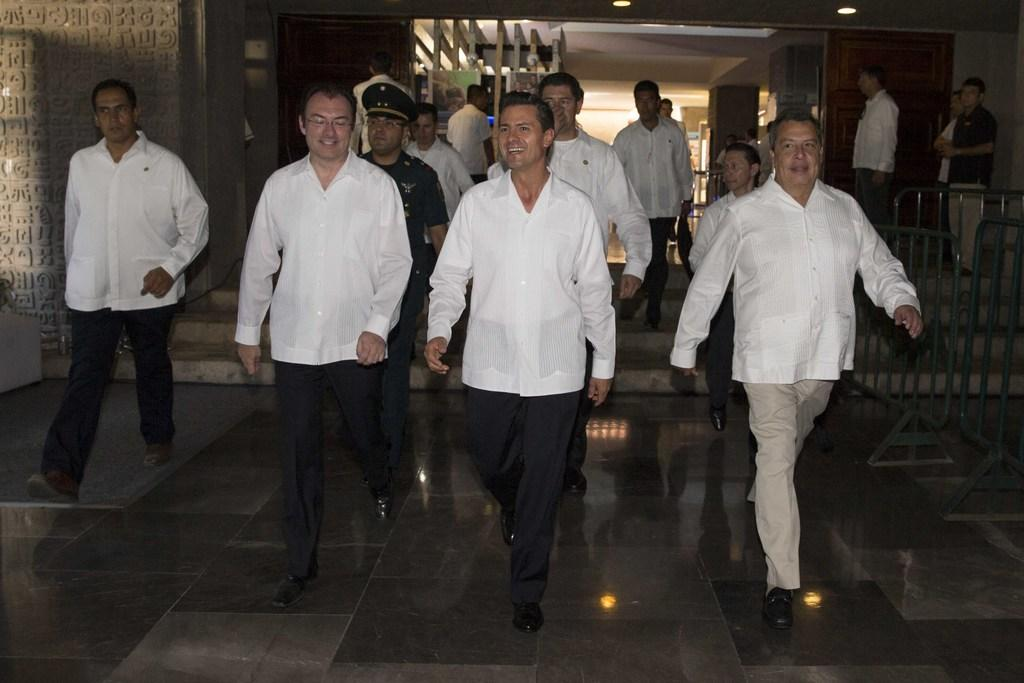How many men are present in the image? There are many men in the image. What are the men wearing in the image? The men are wearing white shirts and shoes. What are the men doing in the image? The men are walking on the floor. What can be seen in the background of the image? There is a building in the background of the image. What is the condition of the building in the image? The building has lights inside it. What is on the right side of the image? There is a railing on the right side of the image. Can you tell me how many wings are attached to the yak in the image? There is no yak present in the image, and therefore no wings can be observed. 